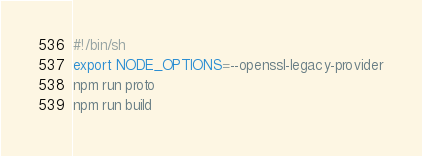Convert code to text. <code><loc_0><loc_0><loc_500><loc_500><_Bash_>#!/bin/sh
export NODE_OPTIONS=--openssl-legacy-provider
npm run proto
npm run build
</code> 